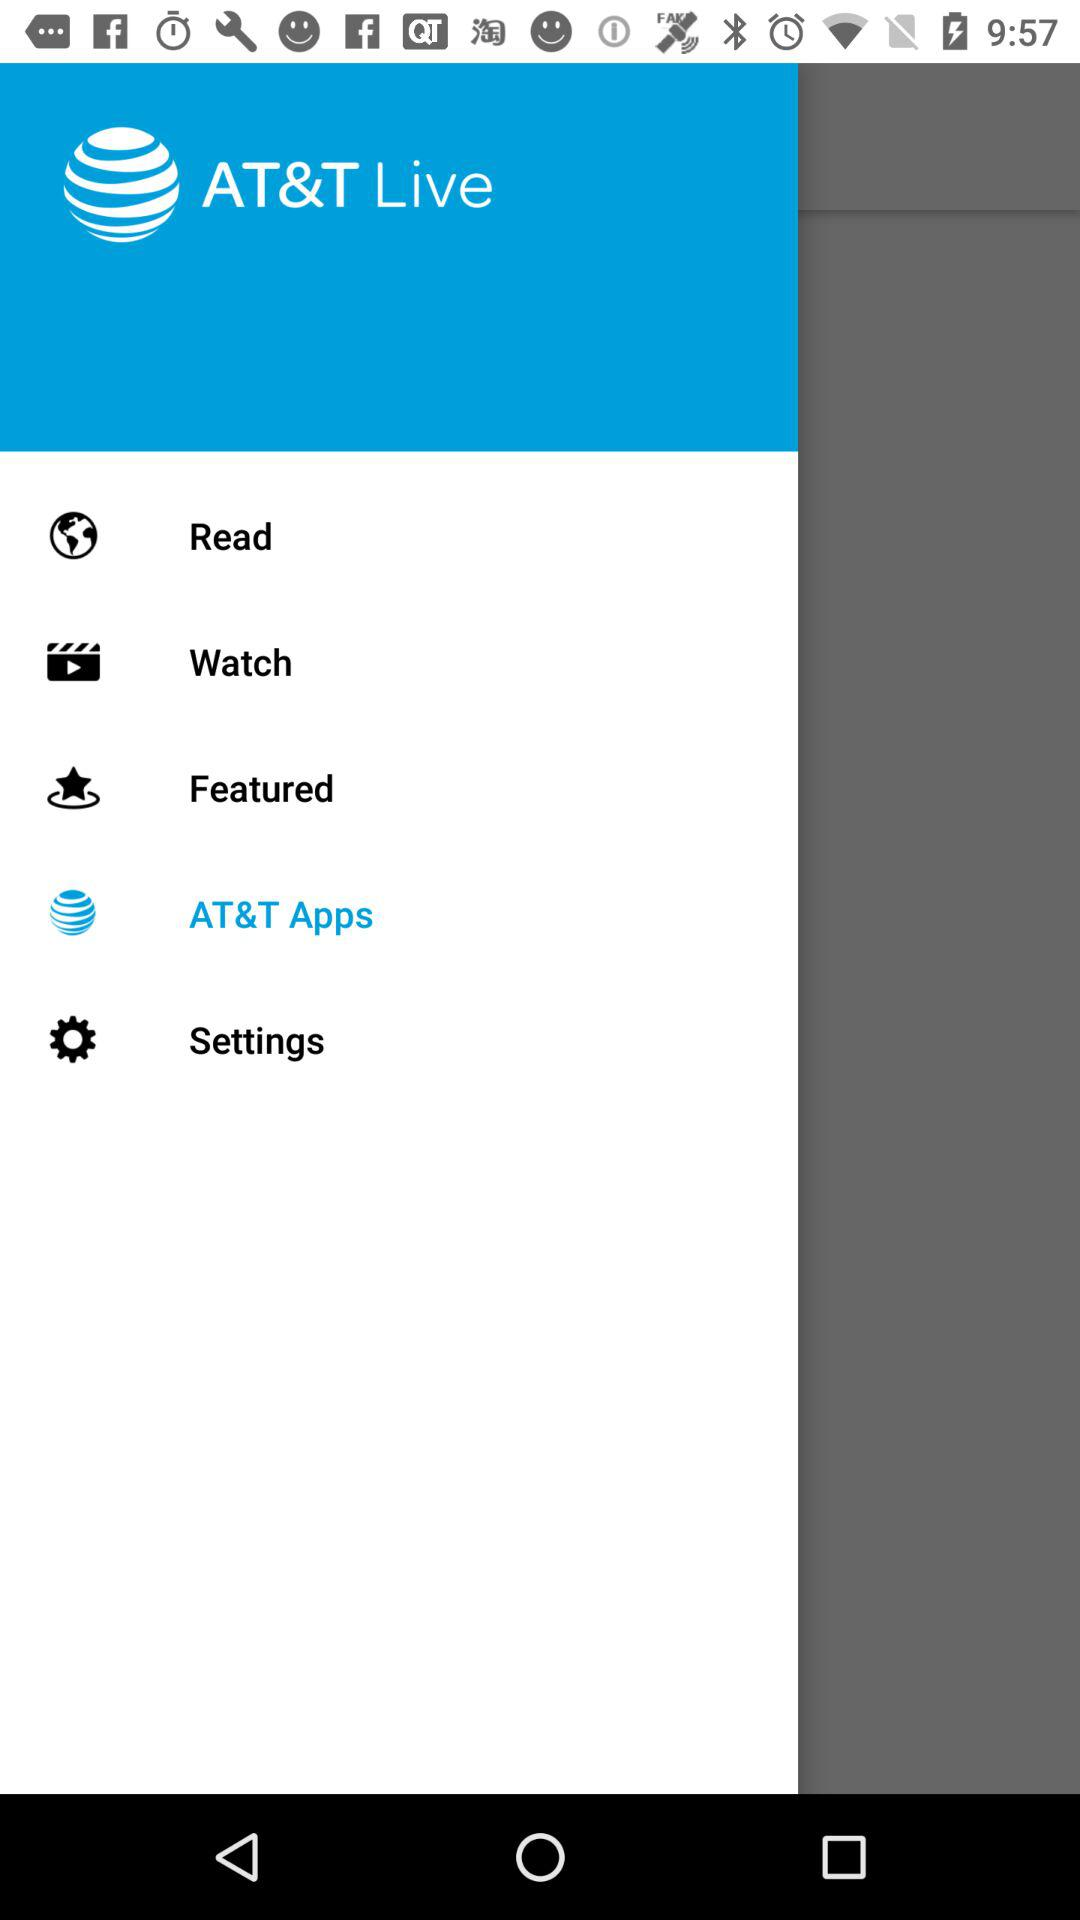What is the application name? The application name is "AT&T Live". 